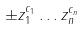<formula> <loc_0><loc_0><loc_500><loc_500>\pm z _ { 1 } ^ { c _ { 1 } } \dots z _ { n } ^ { c _ { n } }</formula> 